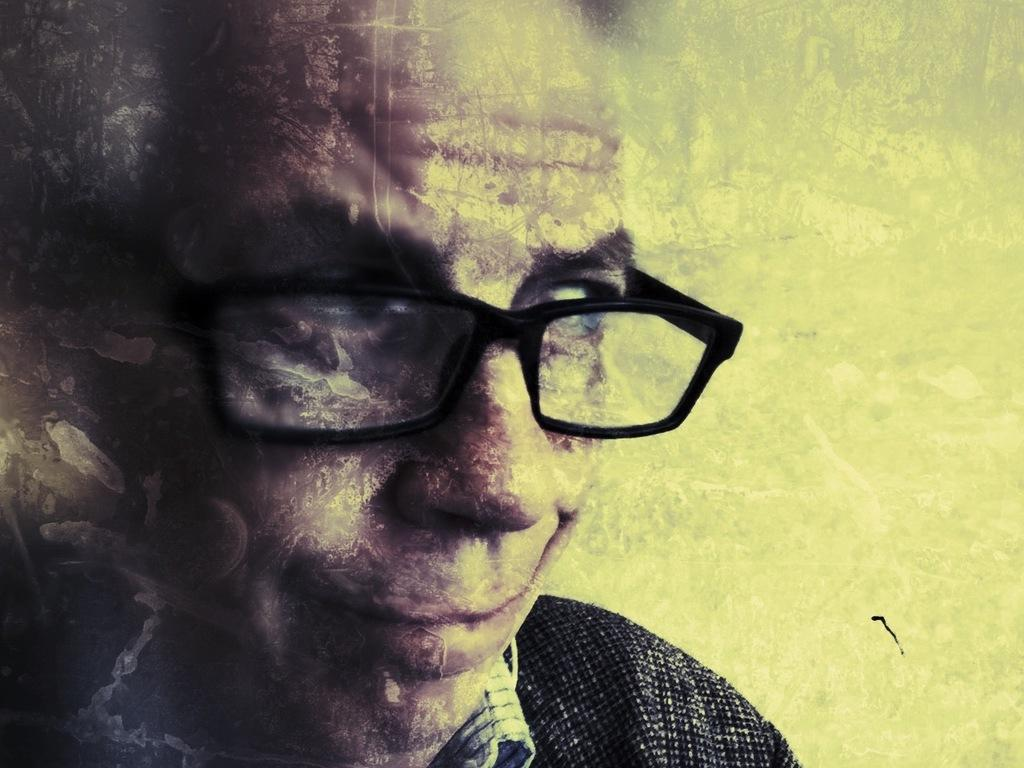What type of picture is the image? The image is an edited picture. Can you describe the person in the image? There is a person in the image. What accessory is the person wearing? The person is wearing glasses. What expression does the person have? The person is smiling. What type of jellyfish can be seen floating in the background of the image? There is no jellyfish present in the image; it features a person wearing glasses and smiling. What type of coal is visible in the person's hand in the image? There is no coal present in the image. 